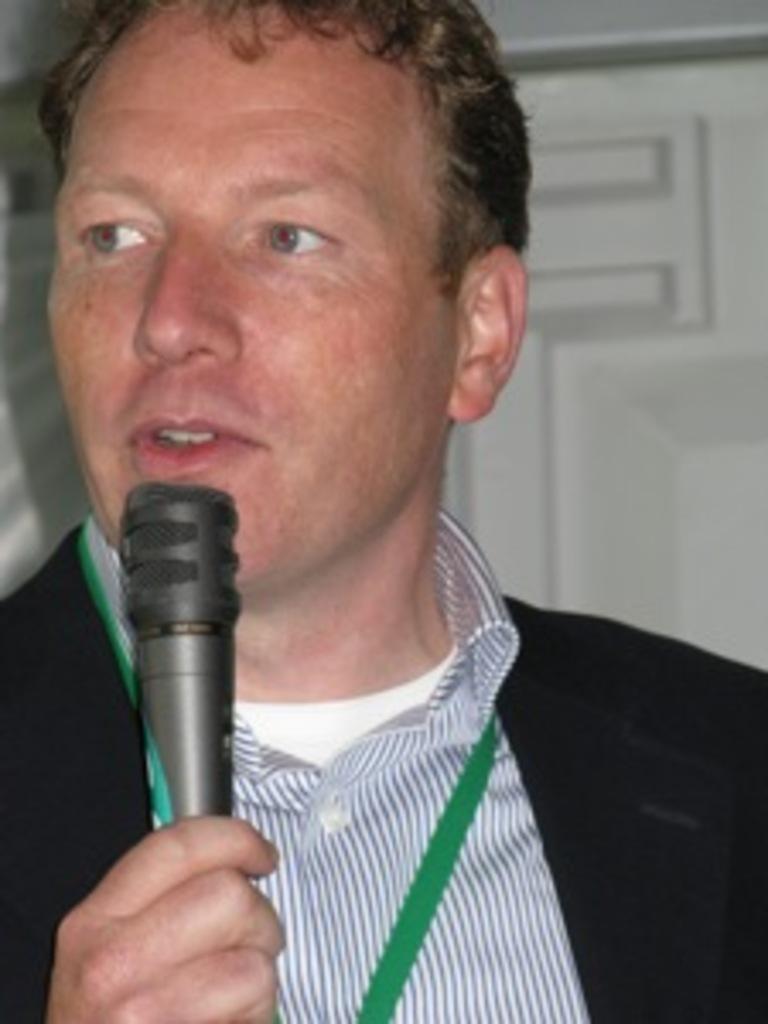Please provide a concise description of this image. In this image there is a man who is holding the mic with his hand. 